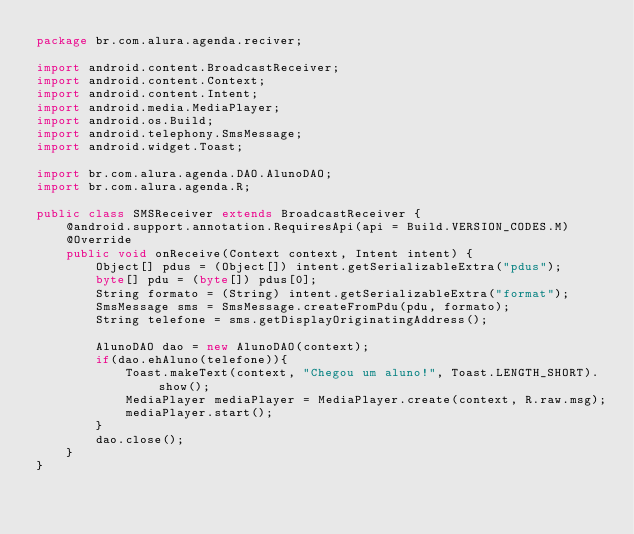Convert code to text. <code><loc_0><loc_0><loc_500><loc_500><_Java_>package br.com.alura.agenda.reciver;

import android.content.BroadcastReceiver;
import android.content.Context;
import android.content.Intent;
import android.media.MediaPlayer;
import android.os.Build;
import android.telephony.SmsMessage;
import android.widget.Toast;

import br.com.alura.agenda.DAO.AlunoDAO;
import br.com.alura.agenda.R;

public class SMSReceiver extends BroadcastReceiver {
    @android.support.annotation.RequiresApi(api = Build.VERSION_CODES.M)
    @Override
    public void onReceive(Context context, Intent intent) {
        Object[] pdus = (Object[]) intent.getSerializableExtra("pdus");
        byte[] pdu = (byte[]) pdus[0];
        String formato = (String) intent.getSerializableExtra("format");
        SmsMessage sms = SmsMessage.createFromPdu(pdu, formato);
        String telefone = sms.getDisplayOriginatingAddress();

        AlunoDAO dao = new AlunoDAO(context);
        if(dao.ehAluno(telefone)){
            Toast.makeText(context, "Chegou um aluno!", Toast.LENGTH_SHORT).show();
            MediaPlayer mediaPlayer = MediaPlayer.create(context, R.raw.msg);
            mediaPlayer.start();
        }
        dao.close();
    }
}
</code> 